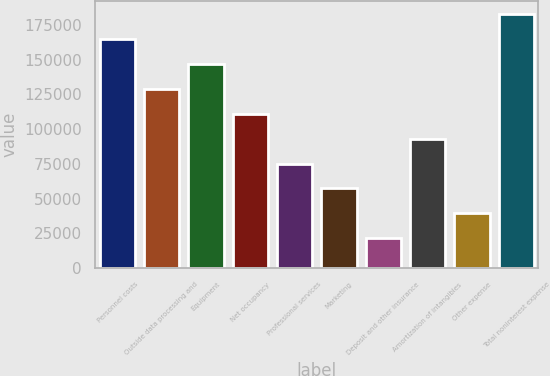Convert chart. <chart><loc_0><loc_0><loc_500><loc_500><bar_chart><fcel>Personnel costs<fcel>Outside data processing and<fcel>Equipment<fcel>Net occupancy<fcel>Professional services<fcel>Marketing<fcel>Deposit and other insurance<fcel>Amortization of intangibles<fcel>Other expense<fcel>Total noninterest expense<nl><fcel>164815<fcel>128984<fcel>146900<fcel>111069<fcel>75237.4<fcel>57321.8<fcel>21490.6<fcel>93153<fcel>39406.2<fcel>182731<nl></chart> 